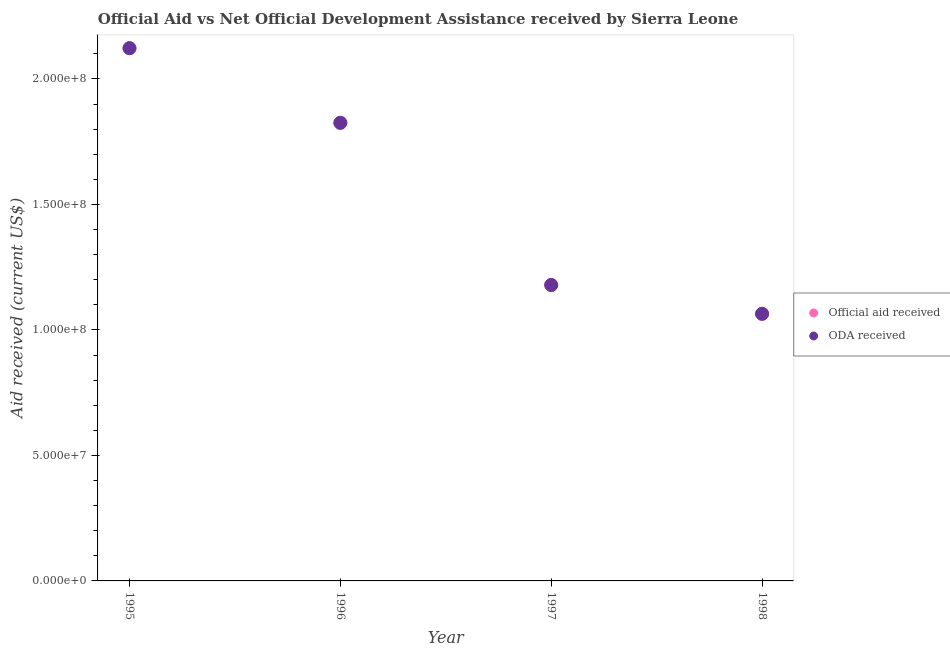Is the number of dotlines equal to the number of legend labels?
Keep it short and to the point. Yes. What is the oda received in 1996?
Your answer should be compact. 1.83e+08. Across all years, what is the maximum official aid received?
Your response must be concise. 2.12e+08. Across all years, what is the minimum oda received?
Provide a succinct answer. 1.06e+08. In which year was the oda received maximum?
Make the answer very short. 1995. What is the total official aid received in the graph?
Your answer should be compact. 6.19e+08. What is the difference between the oda received in 1995 and that in 1996?
Your answer should be compact. 2.98e+07. What is the difference between the official aid received in 1998 and the oda received in 1995?
Offer a very short reply. -1.06e+08. What is the average official aid received per year?
Provide a short and direct response. 1.55e+08. In the year 1996, what is the difference between the oda received and official aid received?
Provide a succinct answer. 0. In how many years, is the oda received greater than 110000000 US$?
Your answer should be very brief. 3. What is the ratio of the official aid received in 1996 to that in 1997?
Provide a succinct answer. 1.55. Is the oda received in 1995 less than that in 1996?
Provide a short and direct response. No. What is the difference between the highest and the second highest oda received?
Offer a terse response. 2.98e+07. What is the difference between the highest and the lowest official aid received?
Give a very brief answer. 1.06e+08. Does the official aid received monotonically increase over the years?
Provide a succinct answer. No. Is the oda received strictly less than the official aid received over the years?
Your answer should be very brief. No. What is the difference between two consecutive major ticks on the Y-axis?
Keep it short and to the point. 5.00e+07. Are the values on the major ticks of Y-axis written in scientific E-notation?
Your answer should be very brief. Yes. Does the graph contain grids?
Your answer should be compact. No. Where does the legend appear in the graph?
Provide a short and direct response. Center right. How are the legend labels stacked?
Your answer should be compact. Vertical. What is the title of the graph?
Give a very brief answer. Official Aid vs Net Official Development Assistance received by Sierra Leone . What is the label or title of the Y-axis?
Make the answer very short. Aid received (current US$). What is the Aid received (current US$) in Official aid received in 1995?
Keep it short and to the point. 2.12e+08. What is the Aid received (current US$) of ODA received in 1995?
Provide a succinct answer. 2.12e+08. What is the Aid received (current US$) of Official aid received in 1996?
Provide a short and direct response. 1.83e+08. What is the Aid received (current US$) in ODA received in 1996?
Ensure brevity in your answer.  1.83e+08. What is the Aid received (current US$) of Official aid received in 1997?
Ensure brevity in your answer.  1.18e+08. What is the Aid received (current US$) of ODA received in 1997?
Your answer should be very brief. 1.18e+08. What is the Aid received (current US$) of Official aid received in 1998?
Your response must be concise. 1.06e+08. What is the Aid received (current US$) of ODA received in 1998?
Your response must be concise. 1.06e+08. Across all years, what is the maximum Aid received (current US$) in Official aid received?
Offer a very short reply. 2.12e+08. Across all years, what is the maximum Aid received (current US$) of ODA received?
Offer a terse response. 2.12e+08. Across all years, what is the minimum Aid received (current US$) of Official aid received?
Provide a succinct answer. 1.06e+08. Across all years, what is the minimum Aid received (current US$) of ODA received?
Offer a very short reply. 1.06e+08. What is the total Aid received (current US$) of Official aid received in the graph?
Your answer should be very brief. 6.19e+08. What is the total Aid received (current US$) of ODA received in the graph?
Your answer should be compact. 6.19e+08. What is the difference between the Aid received (current US$) in Official aid received in 1995 and that in 1996?
Make the answer very short. 2.98e+07. What is the difference between the Aid received (current US$) in ODA received in 1995 and that in 1996?
Your answer should be compact. 2.98e+07. What is the difference between the Aid received (current US$) in Official aid received in 1995 and that in 1997?
Provide a succinct answer. 9.44e+07. What is the difference between the Aid received (current US$) in ODA received in 1995 and that in 1997?
Provide a succinct answer. 9.44e+07. What is the difference between the Aid received (current US$) in Official aid received in 1995 and that in 1998?
Your answer should be very brief. 1.06e+08. What is the difference between the Aid received (current US$) in ODA received in 1995 and that in 1998?
Keep it short and to the point. 1.06e+08. What is the difference between the Aid received (current US$) in Official aid received in 1996 and that in 1997?
Offer a terse response. 6.46e+07. What is the difference between the Aid received (current US$) of ODA received in 1996 and that in 1997?
Your answer should be very brief. 6.46e+07. What is the difference between the Aid received (current US$) in Official aid received in 1996 and that in 1998?
Your response must be concise. 7.61e+07. What is the difference between the Aid received (current US$) in ODA received in 1996 and that in 1998?
Give a very brief answer. 7.61e+07. What is the difference between the Aid received (current US$) in Official aid received in 1997 and that in 1998?
Your answer should be very brief. 1.15e+07. What is the difference between the Aid received (current US$) of ODA received in 1997 and that in 1998?
Make the answer very short. 1.15e+07. What is the difference between the Aid received (current US$) in Official aid received in 1995 and the Aid received (current US$) in ODA received in 1996?
Your response must be concise. 2.98e+07. What is the difference between the Aid received (current US$) of Official aid received in 1995 and the Aid received (current US$) of ODA received in 1997?
Give a very brief answer. 9.44e+07. What is the difference between the Aid received (current US$) in Official aid received in 1995 and the Aid received (current US$) in ODA received in 1998?
Offer a very short reply. 1.06e+08. What is the difference between the Aid received (current US$) of Official aid received in 1996 and the Aid received (current US$) of ODA received in 1997?
Provide a succinct answer. 6.46e+07. What is the difference between the Aid received (current US$) in Official aid received in 1996 and the Aid received (current US$) in ODA received in 1998?
Give a very brief answer. 7.61e+07. What is the difference between the Aid received (current US$) of Official aid received in 1997 and the Aid received (current US$) of ODA received in 1998?
Offer a very short reply. 1.15e+07. What is the average Aid received (current US$) in Official aid received per year?
Provide a short and direct response. 1.55e+08. What is the average Aid received (current US$) of ODA received per year?
Keep it short and to the point. 1.55e+08. In the year 1995, what is the difference between the Aid received (current US$) in Official aid received and Aid received (current US$) in ODA received?
Your answer should be compact. 0. In the year 1997, what is the difference between the Aid received (current US$) of Official aid received and Aid received (current US$) of ODA received?
Ensure brevity in your answer.  0. In the year 1998, what is the difference between the Aid received (current US$) of Official aid received and Aid received (current US$) of ODA received?
Ensure brevity in your answer.  0. What is the ratio of the Aid received (current US$) of Official aid received in 1995 to that in 1996?
Ensure brevity in your answer.  1.16. What is the ratio of the Aid received (current US$) of ODA received in 1995 to that in 1996?
Provide a short and direct response. 1.16. What is the ratio of the Aid received (current US$) of Official aid received in 1995 to that in 1997?
Provide a short and direct response. 1.8. What is the ratio of the Aid received (current US$) in ODA received in 1995 to that in 1997?
Your answer should be compact. 1.8. What is the ratio of the Aid received (current US$) in Official aid received in 1995 to that in 1998?
Make the answer very short. 1.99. What is the ratio of the Aid received (current US$) of ODA received in 1995 to that in 1998?
Keep it short and to the point. 1.99. What is the ratio of the Aid received (current US$) of Official aid received in 1996 to that in 1997?
Your response must be concise. 1.55. What is the ratio of the Aid received (current US$) in ODA received in 1996 to that in 1997?
Provide a succinct answer. 1.55. What is the ratio of the Aid received (current US$) in Official aid received in 1996 to that in 1998?
Offer a very short reply. 1.71. What is the ratio of the Aid received (current US$) in ODA received in 1996 to that in 1998?
Make the answer very short. 1.71. What is the ratio of the Aid received (current US$) in Official aid received in 1997 to that in 1998?
Give a very brief answer. 1.11. What is the ratio of the Aid received (current US$) in ODA received in 1997 to that in 1998?
Your answer should be compact. 1.11. What is the difference between the highest and the second highest Aid received (current US$) in Official aid received?
Offer a very short reply. 2.98e+07. What is the difference between the highest and the second highest Aid received (current US$) of ODA received?
Keep it short and to the point. 2.98e+07. What is the difference between the highest and the lowest Aid received (current US$) of Official aid received?
Your response must be concise. 1.06e+08. What is the difference between the highest and the lowest Aid received (current US$) in ODA received?
Your response must be concise. 1.06e+08. 